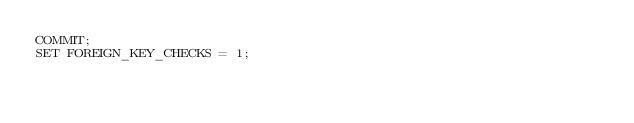Convert code to text. <code><loc_0><loc_0><loc_500><loc_500><_SQL_>COMMIT;
SET FOREIGN_KEY_CHECKS = 1;
</code> 